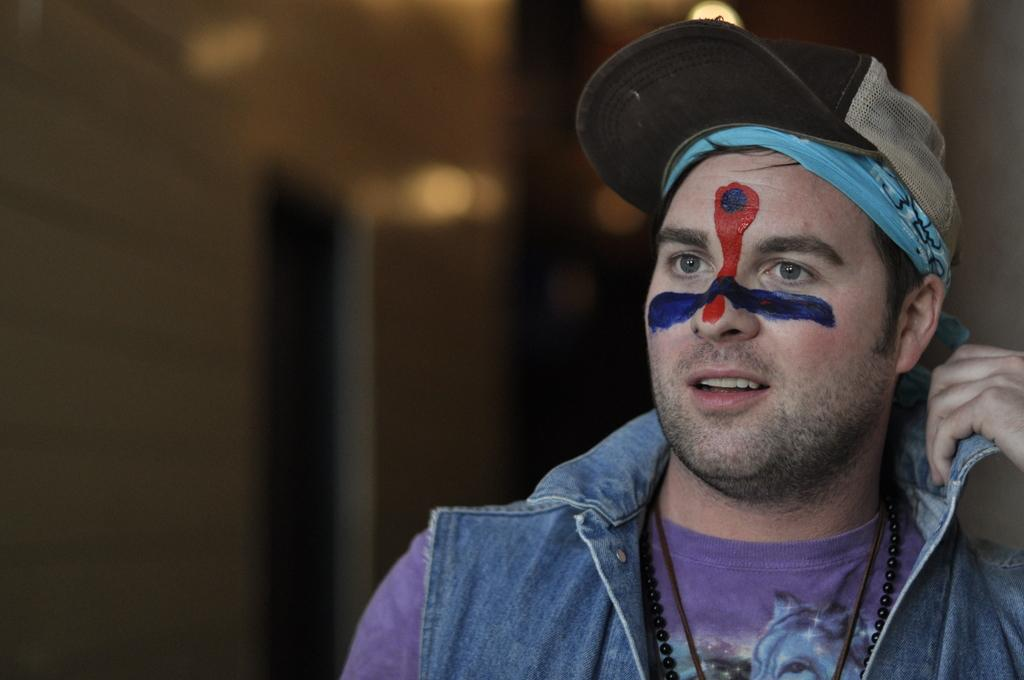Who or what is the main subject in the center of the image? There is a person in the center of the image. What can be seen in the background of the image? There is a wall in the background of the image. What type of war is depicted in the image? There is no war depicted in the image; it features a person and a wall in the background. Can you see any ghosts in the image? There are no ghosts present in the image. 